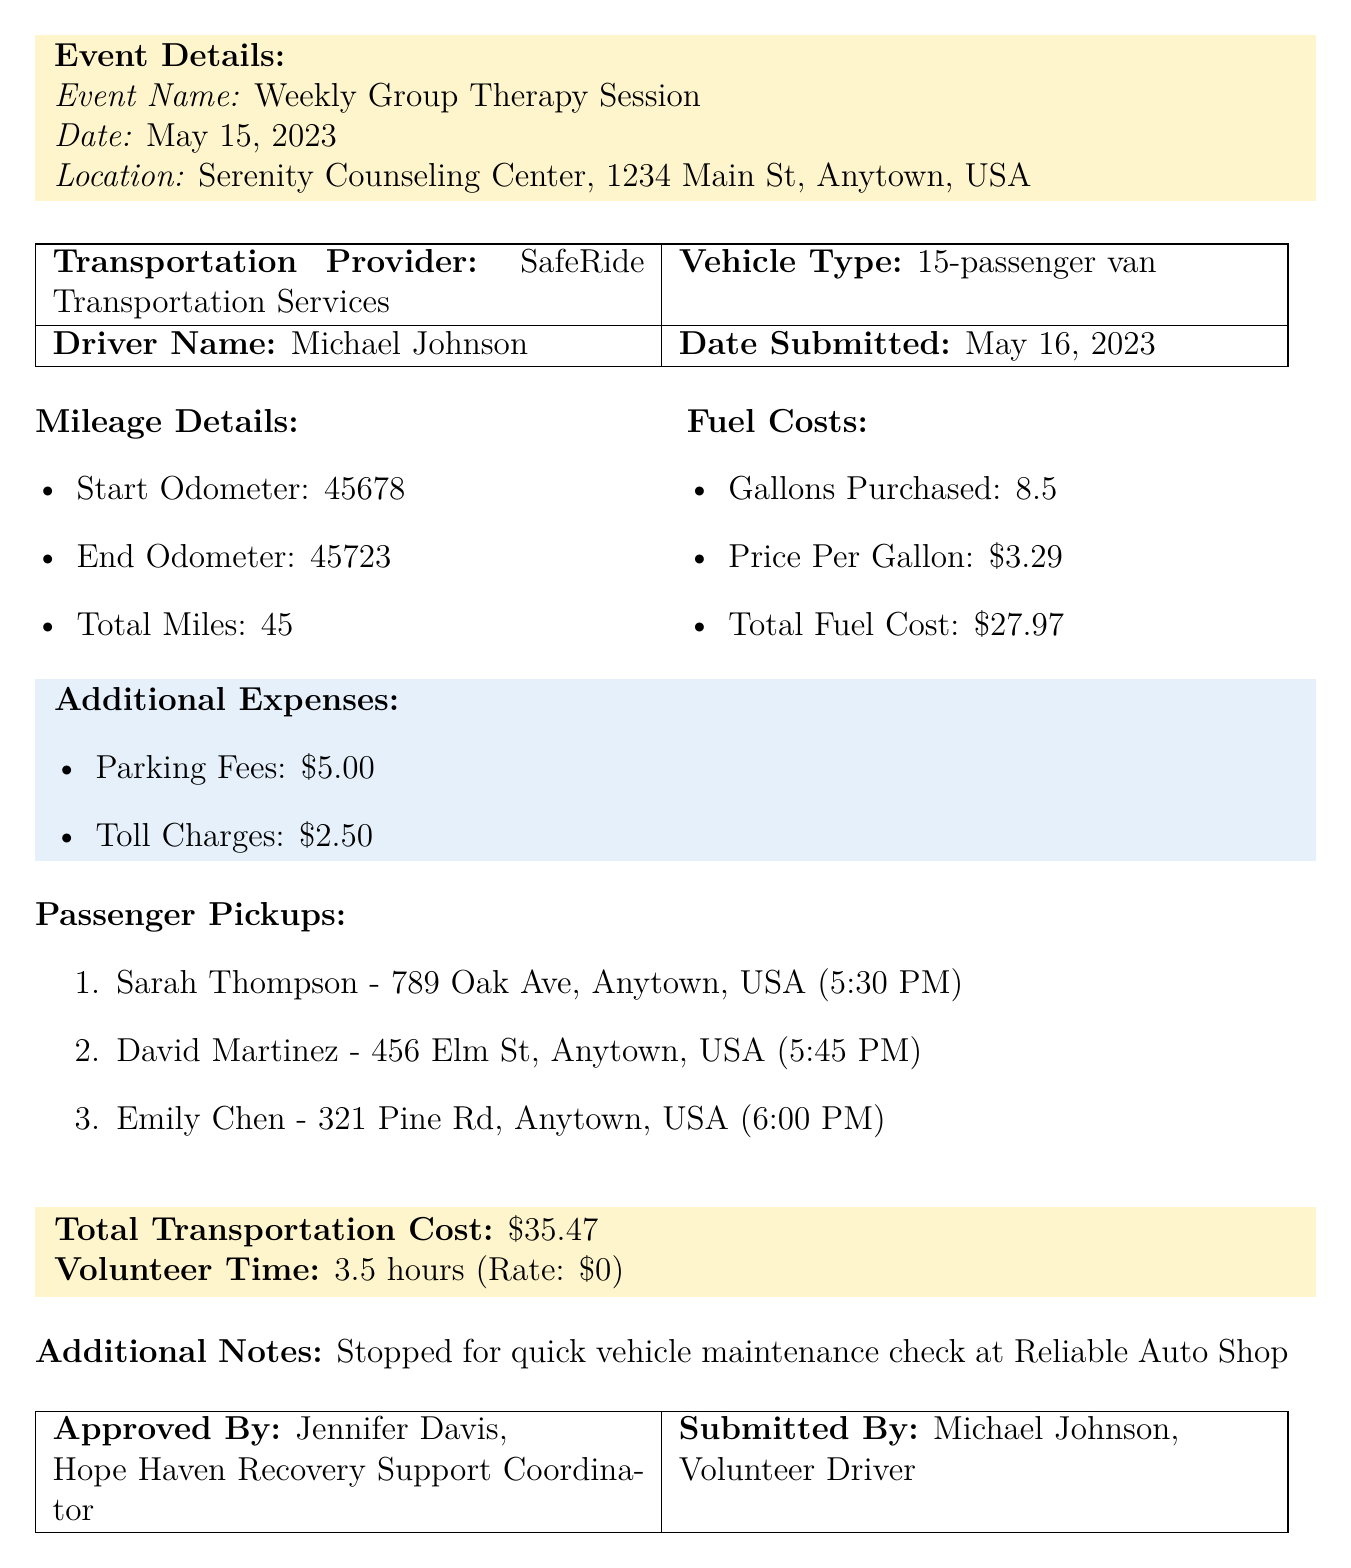What is the name of the organization? The organization's name is stated at the beginning of the document.
Answer: Hope Haven Recovery Support What is the total transportation cost? The total transportation cost is clearly indicated in the summary section of the document.
Answer: $35.47 Who approved the expense report? The person who approved the report is mentioned in the approval section of the document.
Answer: Jennifer Davis What was the mileage driven for this trip? The total mileage is detailed under the mileage section of the document.
Answer: 45 How many gallons of fuel were purchased? The number of gallons purchased is specified in the fuel costs section.
Answer: 8.5 What is the price per gallon of fuel? This information can be found in the fuel costs section of the document.
Answer: $3.29 How many passenger pickups were made? The number of passengers picked up is indicated in the passenger pickups list.
Answer: 3 What time was Sarah Thompson picked up? Her pickup time is documented in the passenger pickups section of the document.
Answer: 5:30 PM What type of vehicle was used for transportation? The type of vehicle is listed in the transportation details of the report.
Answer: 15-passenger van 